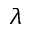Convert formula to latex. <formula><loc_0><loc_0><loc_500><loc_500>\lambda</formula> 